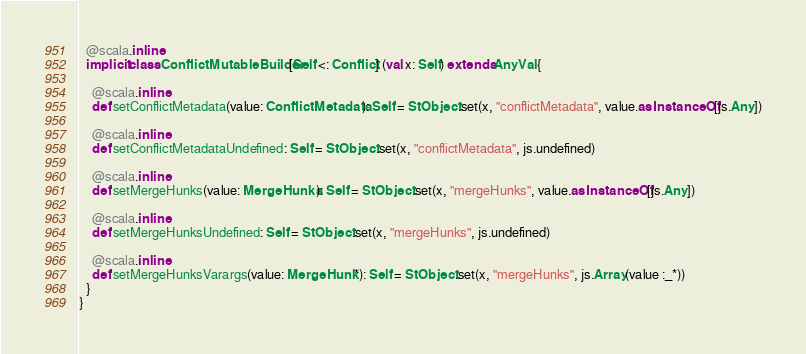Convert code to text. <code><loc_0><loc_0><loc_500><loc_500><_Scala_>  @scala.inline
  implicit class ConflictMutableBuilder[Self <: Conflict] (val x: Self) extends AnyVal {
    
    @scala.inline
    def setConflictMetadata(value: ConflictMetadata): Self = StObject.set(x, "conflictMetadata", value.asInstanceOf[js.Any])
    
    @scala.inline
    def setConflictMetadataUndefined: Self = StObject.set(x, "conflictMetadata", js.undefined)
    
    @scala.inline
    def setMergeHunks(value: MergeHunks): Self = StObject.set(x, "mergeHunks", value.asInstanceOf[js.Any])
    
    @scala.inline
    def setMergeHunksUndefined: Self = StObject.set(x, "mergeHunks", js.undefined)
    
    @scala.inline
    def setMergeHunksVarargs(value: MergeHunk*): Self = StObject.set(x, "mergeHunks", js.Array(value :_*))
  }
}
</code> 